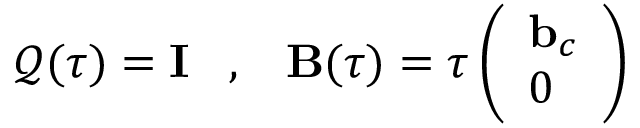<formula> <loc_0><loc_0><loc_500><loc_500>\mathcal { Q } ( \tau ) = { \mathbf I } \, , \, { \mathbf B } ( \tau ) = \tau \left ( \begin{array} { l } { { \mathbf b } _ { c } } \\ { 0 } \end{array} \right )</formula> 